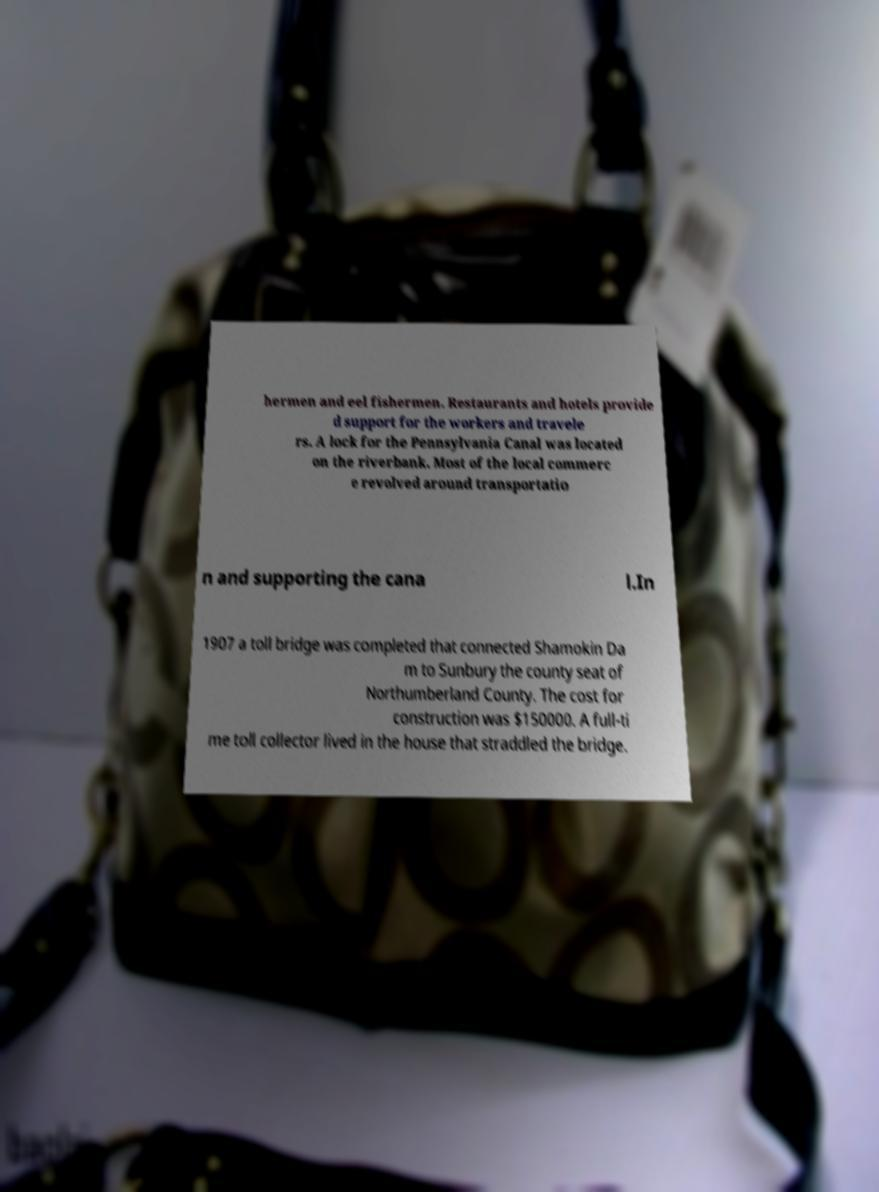For documentation purposes, I need the text within this image transcribed. Could you provide that? hermen and eel fishermen. Restaurants and hotels provide d support for the workers and travele rs. A lock for the Pennsylvania Canal was located on the riverbank. Most of the local commerc e revolved around transportatio n and supporting the cana l.In 1907 a toll bridge was completed that connected Shamokin Da m to Sunbury the county seat of Northumberland County. The cost for construction was $150000. A full-ti me toll collector lived in the house that straddled the bridge. 